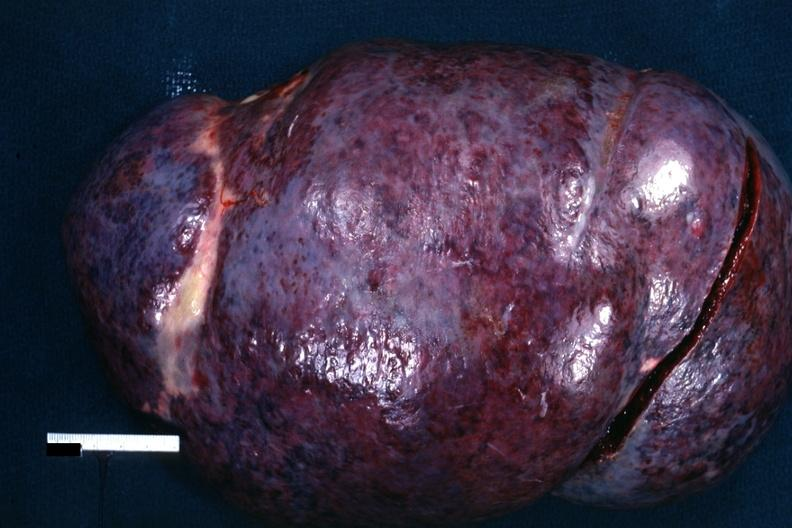where is this part in?
Answer the question using a single word or phrase. Spleen 